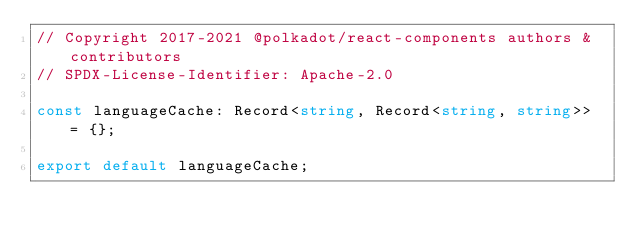Convert code to text. <code><loc_0><loc_0><loc_500><loc_500><_TypeScript_>// Copyright 2017-2021 @polkadot/react-components authors & contributors
// SPDX-License-Identifier: Apache-2.0

const languageCache: Record<string, Record<string, string>> = {};

export default languageCache;
</code> 